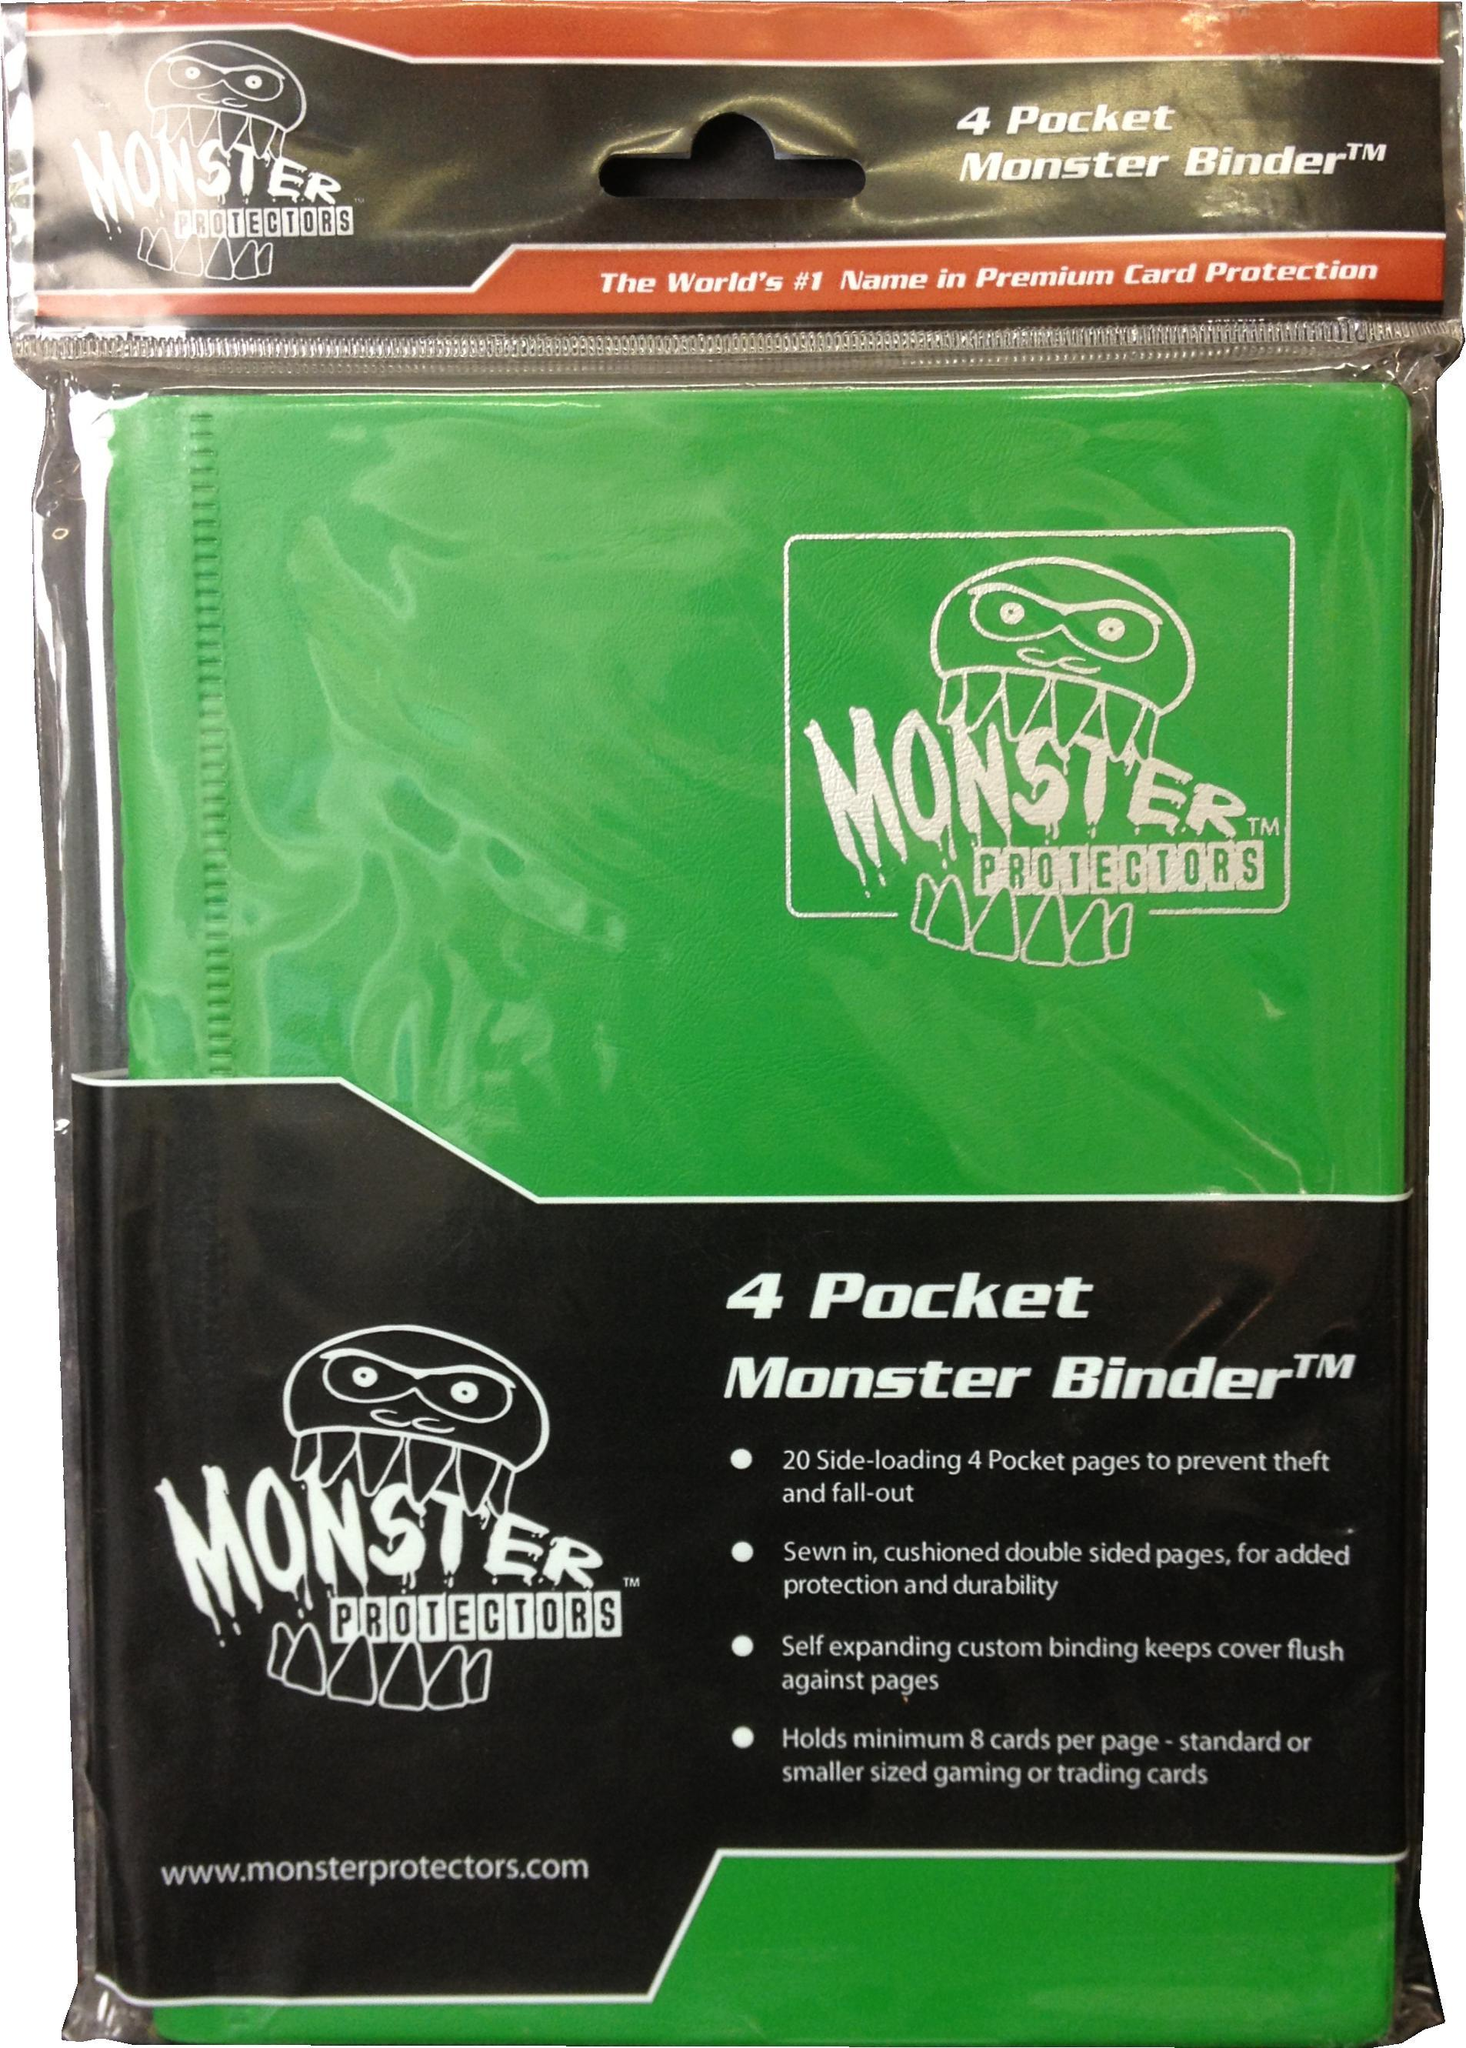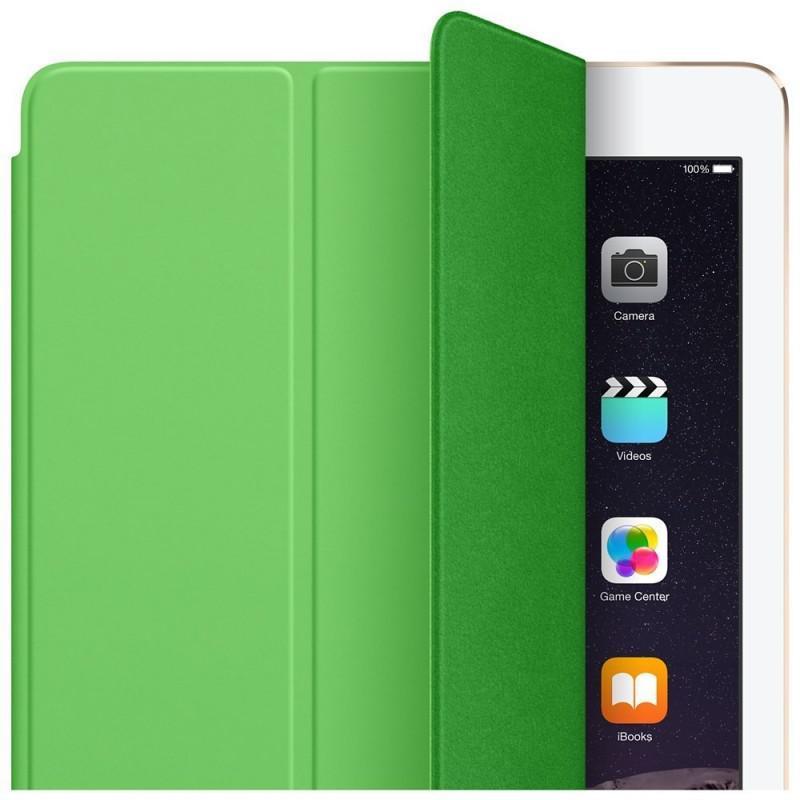The first image is the image on the left, the second image is the image on the right. Assess this claim about the two images: "The right image shows two binders.". Correct or not? Answer yes or no. No. 